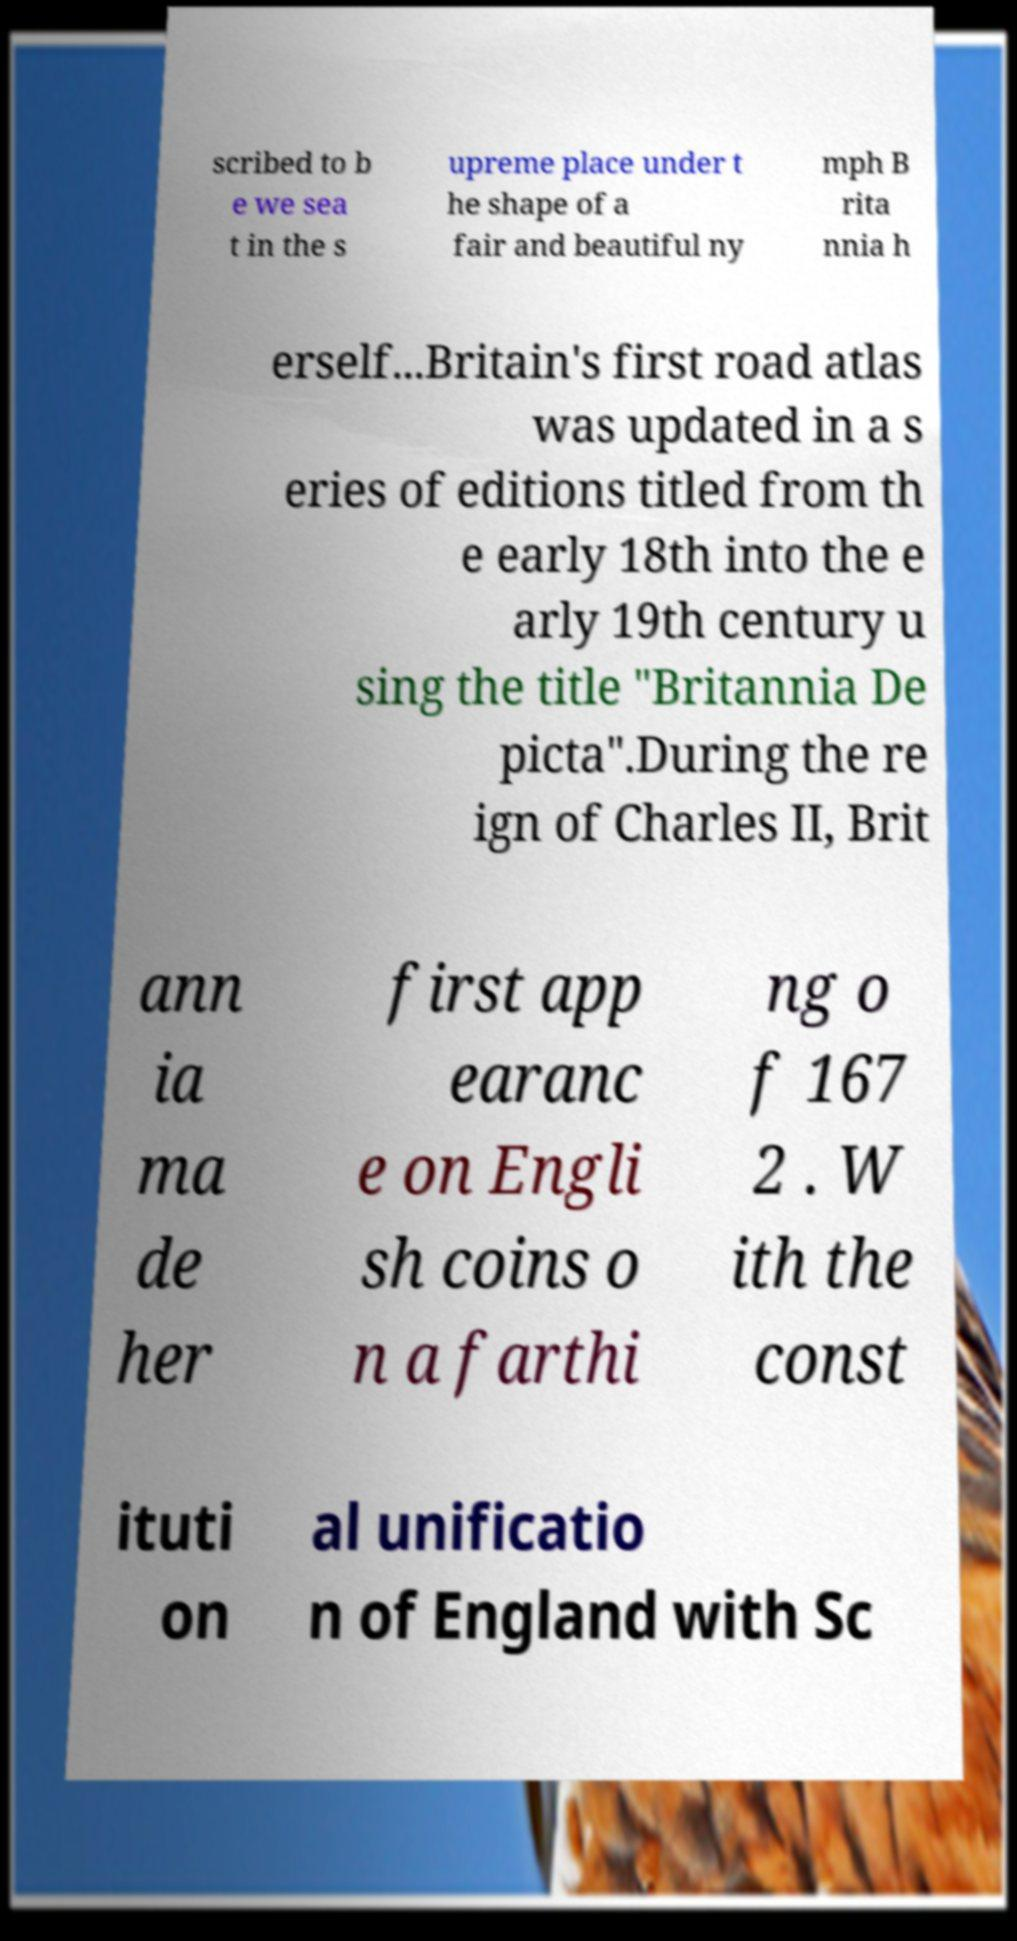For documentation purposes, I need the text within this image transcribed. Could you provide that? scribed to b e we sea t in the s upreme place under t he shape of a fair and beautiful ny mph B rita nnia h erself...Britain's first road atlas was updated in a s eries of editions titled from th e early 18th into the e arly 19th century u sing the title "Britannia De picta".During the re ign of Charles II, Brit ann ia ma de her first app earanc e on Engli sh coins o n a farthi ng o f 167 2 . W ith the const ituti on al unificatio n of England with Sc 